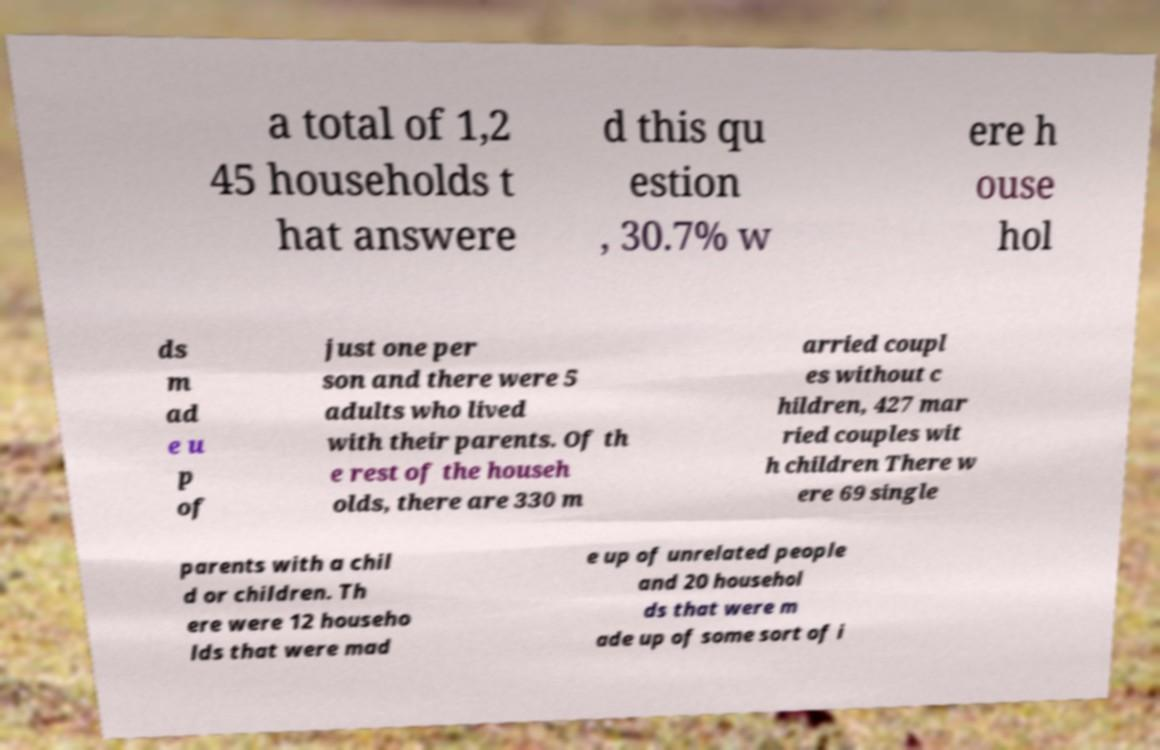Can you read and provide the text displayed in the image?This photo seems to have some interesting text. Can you extract and type it out for me? a total of 1,2 45 households t hat answere d this qu estion , 30.7% w ere h ouse hol ds m ad e u p of just one per son and there were 5 adults who lived with their parents. Of th e rest of the househ olds, there are 330 m arried coupl es without c hildren, 427 mar ried couples wit h children There w ere 69 single parents with a chil d or children. Th ere were 12 househo lds that were mad e up of unrelated people and 20 househol ds that were m ade up of some sort of i 